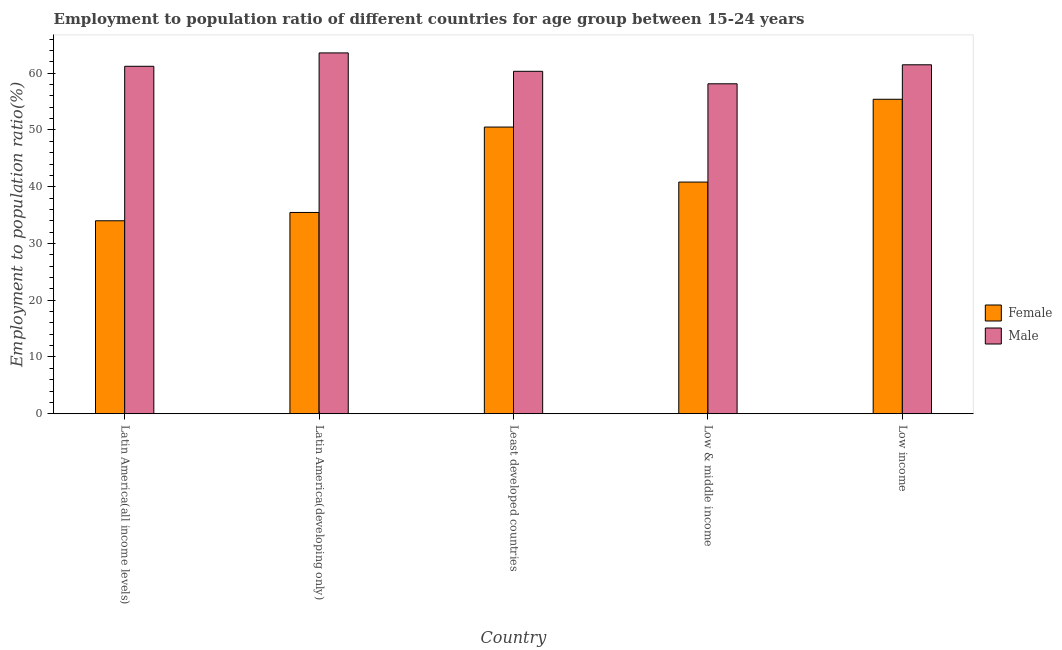How many different coloured bars are there?
Offer a terse response. 2. Are the number of bars on each tick of the X-axis equal?
Your answer should be very brief. Yes. What is the label of the 1st group of bars from the left?
Your answer should be compact. Latin America(all income levels). What is the employment to population ratio(female) in Latin America(developing only)?
Your response must be concise. 35.46. Across all countries, what is the maximum employment to population ratio(male)?
Give a very brief answer. 63.57. Across all countries, what is the minimum employment to population ratio(female)?
Make the answer very short. 34. In which country was the employment to population ratio(male) maximum?
Keep it short and to the point. Latin America(developing only). In which country was the employment to population ratio(female) minimum?
Make the answer very short. Latin America(all income levels). What is the total employment to population ratio(female) in the graph?
Ensure brevity in your answer.  216.19. What is the difference between the employment to population ratio(female) in Latin America(all income levels) and that in Latin America(developing only)?
Offer a very short reply. -1.46. What is the difference between the employment to population ratio(male) in Latin America(all income levels) and the employment to population ratio(female) in Latin America(developing only)?
Your answer should be compact. 25.76. What is the average employment to population ratio(female) per country?
Give a very brief answer. 43.24. What is the difference between the employment to population ratio(male) and employment to population ratio(female) in Least developed countries?
Provide a short and direct response. 9.82. In how many countries, is the employment to population ratio(male) greater than 18 %?
Make the answer very short. 5. What is the ratio of the employment to population ratio(male) in Latin America(all income levels) to that in Latin America(developing only)?
Give a very brief answer. 0.96. Is the difference between the employment to population ratio(female) in Latin America(developing only) and Least developed countries greater than the difference between the employment to population ratio(male) in Latin America(developing only) and Least developed countries?
Your answer should be very brief. No. What is the difference between the highest and the second highest employment to population ratio(female)?
Provide a succinct answer. 4.9. What is the difference between the highest and the lowest employment to population ratio(male)?
Your answer should be very brief. 5.44. In how many countries, is the employment to population ratio(female) greater than the average employment to population ratio(female) taken over all countries?
Provide a short and direct response. 2. What does the 1st bar from the right in Low income represents?
Offer a very short reply. Male. Does the graph contain any zero values?
Your answer should be very brief. No. Where does the legend appear in the graph?
Provide a succinct answer. Center right. How are the legend labels stacked?
Provide a short and direct response. Vertical. What is the title of the graph?
Keep it short and to the point. Employment to population ratio of different countries for age group between 15-24 years. Does "Taxes on profits and capital gains" appear as one of the legend labels in the graph?
Give a very brief answer. No. What is the label or title of the X-axis?
Offer a very short reply. Country. What is the label or title of the Y-axis?
Ensure brevity in your answer.  Employment to population ratio(%). What is the Employment to population ratio(%) in Female in Latin America(all income levels)?
Your answer should be compact. 34. What is the Employment to population ratio(%) of Male in Latin America(all income levels)?
Keep it short and to the point. 61.22. What is the Employment to population ratio(%) of Female in Latin America(developing only)?
Give a very brief answer. 35.46. What is the Employment to population ratio(%) in Male in Latin America(developing only)?
Give a very brief answer. 63.57. What is the Employment to population ratio(%) in Female in Least developed countries?
Provide a succinct answer. 50.51. What is the Employment to population ratio(%) in Male in Least developed countries?
Your answer should be compact. 60.33. What is the Employment to population ratio(%) in Female in Low & middle income?
Offer a terse response. 40.82. What is the Employment to population ratio(%) in Male in Low & middle income?
Offer a terse response. 58.13. What is the Employment to population ratio(%) in Female in Low income?
Ensure brevity in your answer.  55.41. What is the Employment to population ratio(%) of Male in Low income?
Ensure brevity in your answer.  61.48. Across all countries, what is the maximum Employment to population ratio(%) in Female?
Provide a succinct answer. 55.41. Across all countries, what is the maximum Employment to population ratio(%) of Male?
Offer a very short reply. 63.57. Across all countries, what is the minimum Employment to population ratio(%) in Female?
Provide a succinct answer. 34. Across all countries, what is the minimum Employment to population ratio(%) in Male?
Your response must be concise. 58.13. What is the total Employment to population ratio(%) of Female in the graph?
Give a very brief answer. 216.19. What is the total Employment to population ratio(%) in Male in the graph?
Offer a terse response. 304.74. What is the difference between the Employment to population ratio(%) of Female in Latin America(all income levels) and that in Latin America(developing only)?
Offer a very short reply. -1.46. What is the difference between the Employment to population ratio(%) in Male in Latin America(all income levels) and that in Latin America(developing only)?
Provide a short and direct response. -2.35. What is the difference between the Employment to population ratio(%) in Female in Latin America(all income levels) and that in Least developed countries?
Make the answer very short. -16.51. What is the difference between the Employment to population ratio(%) of Male in Latin America(all income levels) and that in Least developed countries?
Provide a succinct answer. 0.88. What is the difference between the Employment to population ratio(%) in Female in Latin America(all income levels) and that in Low & middle income?
Provide a short and direct response. -6.82. What is the difference between the Employment to population ratio(%) of Male in Latin America(all income levels) and that in Low & middle income?
Ensure brevity in your answer.  3.09. What is the difference between the Employment to population ratio(%) of Female in Latin America(all income levels) and that in Low income?
Your answer should be compact. -21.41. What is the difference between the Employment to population ratio(%) in Male in Latin America(all income levels) and that in Low income?
Make the answer very short. -0.26. What is the difference between the Employment to population ratio(%) in Female in Latin America(developing only) and that in Least developed countries?
Your answer should be compact. -15.05. What is the difference between the Employment to population ratio(%) of Male in Latin America(developing only) and that in Least developed countries?
Keep it short and to the point. 3.24. What is the difference between the Employment to population ratio(%) of Female in Latin America(developing only) and that in Low & middle income?
Provide a short and direct response. -5.36. What is the difference between the Employment to population ratio(%) in Male in Latin America(developing only) and that in Low & middle income?
Offer a terse response. 5.44. What is the difference between the Employment to population ratio(%) in Female in Latin America(developing only) and that in Low income?
Provide a short and direct response. -19.94. What is the difference between the Employment to population ratio(%) in Male in Latin America(developing only) and that in Low income?
Give a very brief answer. 2.09. What is the difference between the Employment to population ratio(%) in Female in Least developed countries and that in Low & middle income?
Your response must be concise. 9.69. What is the difference between the Employment to population ratio(%) of Male in Least developed countries and that in Low & middle income?
Provide a short and direct response. 2.2. What is the difference between the Employment to population ratio(%) in Female in Least developed countries and that in Low income?
Give a very brief answer. -4.9. What is the difference between the Employment to population ratio(%) in Male in Least developed countries and that in Low income?
Offer a terse response. -1.15. What is the difference between the Employment to population ratio(%) of Female in Low & middle income and that in Low income?
Provide a succinct answer. -14.59. What is the difference between the Employment to population ratio(%) in Male in Low & middle income and that in Low income?
Your response must be concise. -3.35. What is the difference between the Employment to population ratio(%) of Female in Latin America(all income levels) and the Employment to population ratio(%) of Male in Latin America(developing only)?
Your response must be concise. -29.57. What is the difference between the Employment to population ratio(%) in Female in Latin America(all income levels) and the Employment to population ratio(%) in Male in Least developed countries?
Provide a short and direct response. -26.33. What is the difference between the Employment to population ratio(%) of Female in Latin America(all income levels) and the Employment to population ratio(%) of Male in Low & middle income?
Your answer should be very brief. -24.13. What is the difference between the Employment to population ratio(%) in Female in Latin America(all income levels) and the Employment to population ratio(%) in Male in Low income?
Provide a short and direct response. -27.48. What is the difference between the Employment to population ratio(%) in Female in Latin America(developing only) and the Employment to population ratio(%) in Male in Least developed countries?
Offer a terse response. -24.87. What is the difference between the Employment to population ratio(%) in Female in Latin America(developing only) and the Employment to population ratio(%) in Male in Low & middle income?
Provide a succinct answer. -22.67. What is the difference between the Employment to population ratio(%) in Female in Latin America(developing only) and the Employment to population ratio(%) in Male in Low income?
Provide a succinct answer. -26.02. What is the difference between the Employment to population ratio(%) in Female in Least developed countries and the Employment to population ratio(%) in Male in Low & middle income?
Keep it short and to the point. -7.62. What is the difference between the Employment to population ratio(%) in Female in Least developed countries and the Employment to population ratio(%) in Male in Low income?
Ensure brevity in your answer.  -10.97. What is the difference between the Employment to population ratio(%) in Female in Low & middle income and the Employment to population ratio(%) in Male in Low income?
Offer a terse response. -20.66. What is the average Employment to population ratio(%) in Female per country?
Make the answer very short. 43.24. What is the average Employment to population ratio(%) in Male per country?
Provide a succinct answer. 60.95. What is the difference between the Employment to population ratio(%) in Female and Employment to population ratio(%) in Male in Latin America(all income levels)?
Ensure brevity in your answer.  -27.22. What is the difference between the Employment to population ratio(%) in Female and Employment to population ratio(%) in Male in Latin America(developing only)?
Provide a short and direct response. -28.11. What is the difference between the Employment to population ratio(%) in Female and Employment to population ratio(%) in Male in Least developed countries?
Keep it short and to the point. -9.82. What is the difference between the Employment to population ratio(%) of Female and Employment to population ratio(%) of Male in Low & middle income?
Your response must be concise. -17.31. What is the difference between the Employment to population ratio(%) in Female and Employment to population ratio(%) in Male in Low income?
Make the answer very short. -6.08. What is the ratio of the Employment to population ratio(%) of Female in Latin America(all income levels) to that in Latin America(developing only)?
Keep it short and to the point. 0.96. What is the ratio of the Employment to population ratio(%) in Male in Latin America(all income levels) to that in Latin America(developing only)?
Ensure brevity in your answer.  0.96. What is the ratio of the Employment to population ratio(%) of Female in Latin America(all income levels) to that in Least developed countries?
Give a very brief answer. 0.67. What is the ratio of the Employment to population ratio(%) in Male in Latin America(all income levels) to that in Least developed countries?
Ensure brevity in your answer.  1.01. What is the ratio of the Employment to population ratio(%) of Female in Latin America(all income levels) to that in Low & middle income?
Your answer should be compact. 0.83. What is the ratio of the Employment to population ratio(%) of Male in Latin America(all income levels) to that in Low & middle income?
Your answer should be compact. 1.05. What is the ratio of the Employment to population ratio(%) of Female in Latin America(all income levels) to that in Low income?
Offer a terse response. 0.61. What is the ratio of the Employment to population ratio(%) of Male in Latin America(all income levels) to that in Low income?
Provide a succinct answer. 1. What is the ratio of the Employment to population ratio(%) of Female in Latin America(developing only) to that in Least developed countries?
Offer a very short reply. 0.7. What is the ratio of the Employment to population ratio(%) of Male in Latin America(developing only) to that in Least developed countries?
Keep it short and to the point. 1.05. What is the ratio of the Employment to population ratio(%) of Female in Latin America(developing only) to that in Low & middle income?
Make the answer very short. 0.87. What is the ratio of the Employment to population ratio(%) of Male in Latin America(developing only) to that in Low & middle income?
Your response must be concise. 1.09. What is the ratio of the Employment to population ratio(%) of Female in Latin America(developing only) to that in Low income?
Make the answer very short. 0.64. What is the ratio of the Employment to population ratio(%) of Male in Latin America(developing only) to that in Low income?
Your response must be concise. 1.03. What is the ratio of the Employment to population ratio(%) of Female in Least developed countries to that in Low & middle income?
Provide a short and direct response. 1.24. What is the ratio of the Employment to population ratio(%) of Male in Least developed countries to that in Low & middle income?
Provide a succinct answer. 1.04. What is the ratio of the Employment to population ratio(%) of Female in Least developed countries to that in Low income?
Your answer should be compact. 0.91. What is the ratio of the Employment to population ratio(%) in Male in Least developed countries to that in Low income?
Your response must be concise. 0.98. What is the ratio of the Employment to population ratio(%) of Female in Low & middle income to that in Low income?
Your response must be concise. 0.74. What is the ratio of the Employment to population ratio(%) in Male in Low & middle income to that in Low income?
Ensure brevity in your answer.  0.95. What is the difference between the highest and the second highest Employment to population ratio(%) in Female?
Keep it short and to the point. 4.9. What is the difference between the highest and the second highest Employment to population ratio(%) in Male?
Keep it short and to the point. 2.09. What is the difference between the highest and the lowest Employment to population ratio(%) of Female?
Keep it short and to the point. 21.41. What is the difference between the highest and the lowest Employment to population ratio(%) in Male?
Provide a short and direct response. 5.44. 